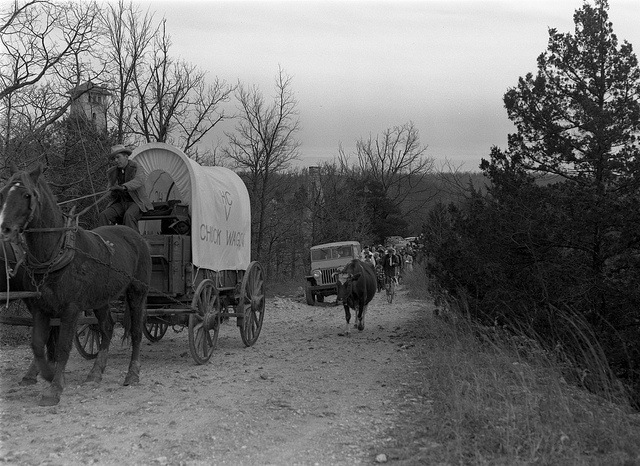Describe the objects in this image and their specific colors. I can see horse in white, black, gray, darkgray, and lightgray tones, people in black, gray, and white tones, truck in white, gray, black, and lightgray tones, car in white, gray, black, and lightgray tones, and cow in black, gray, and white tones in this image. 